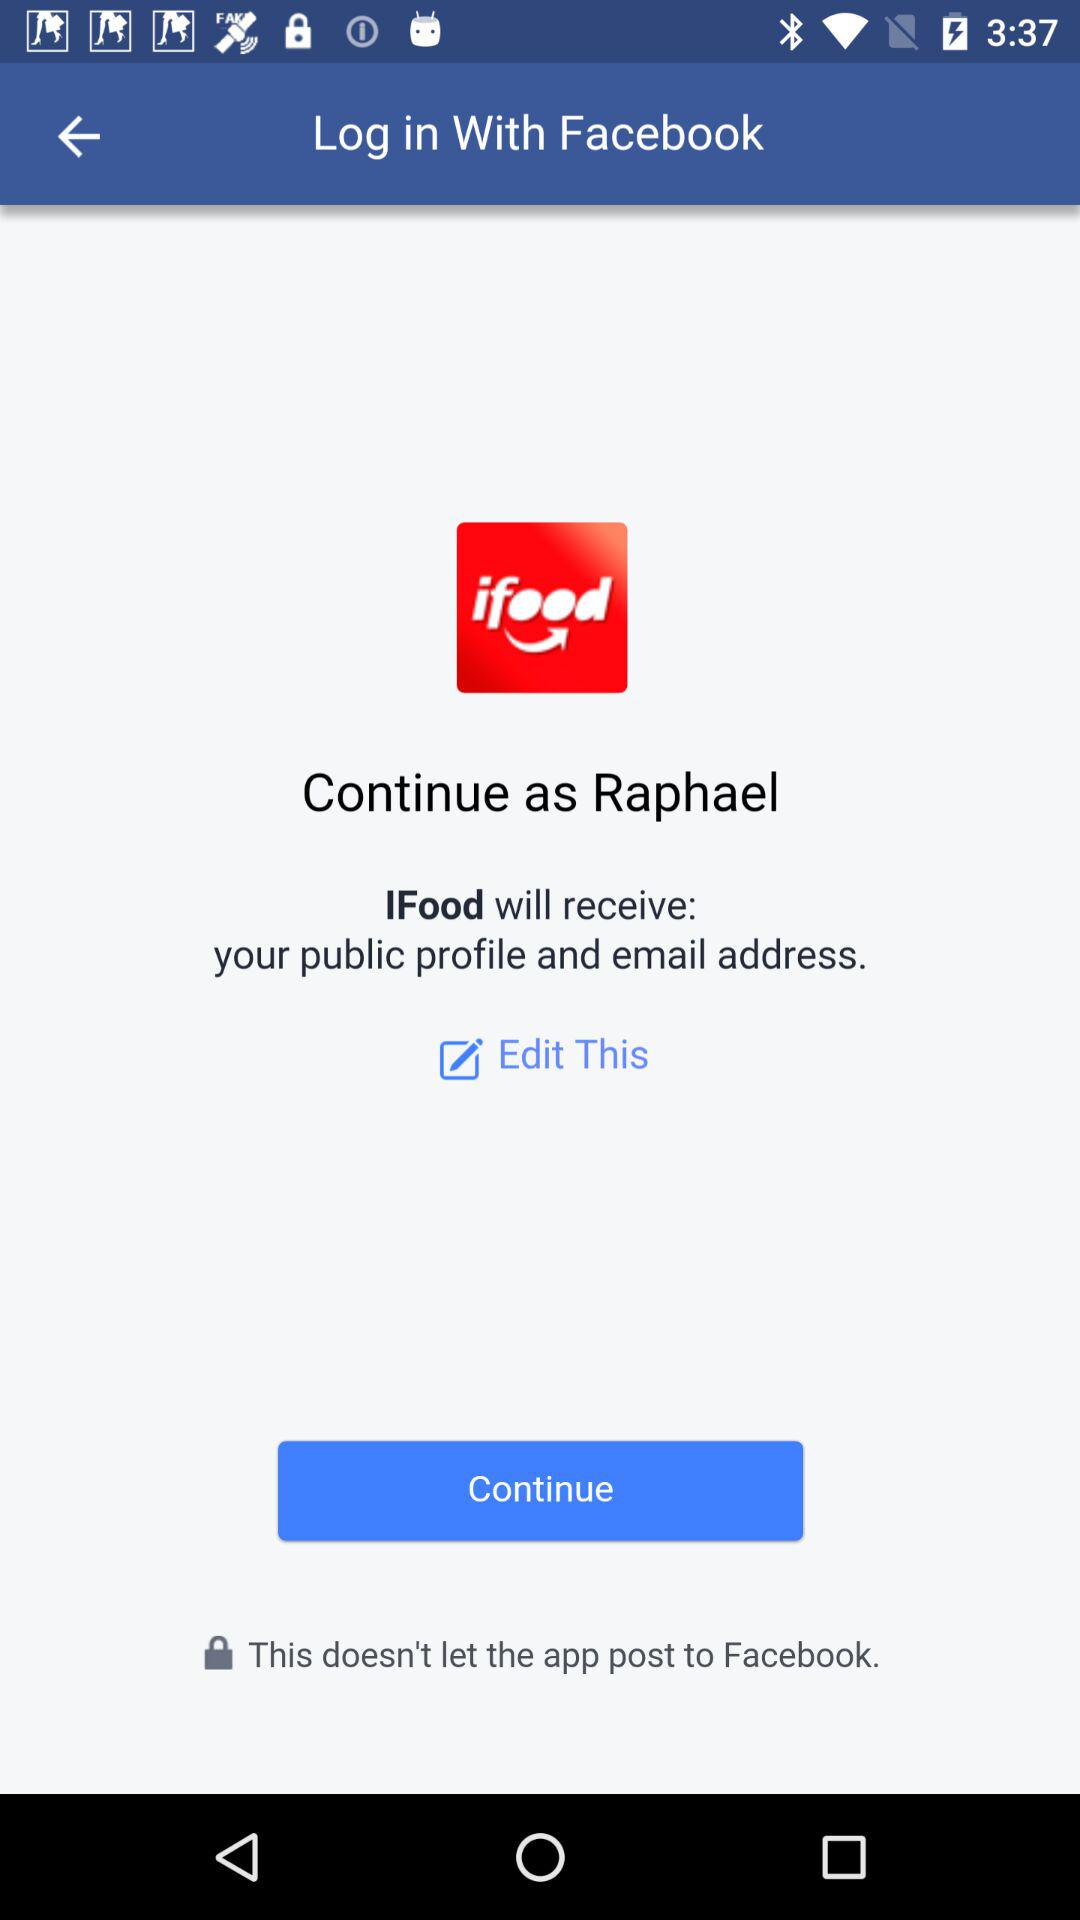What application will receive my public profile and email address? The application is "IFood". 